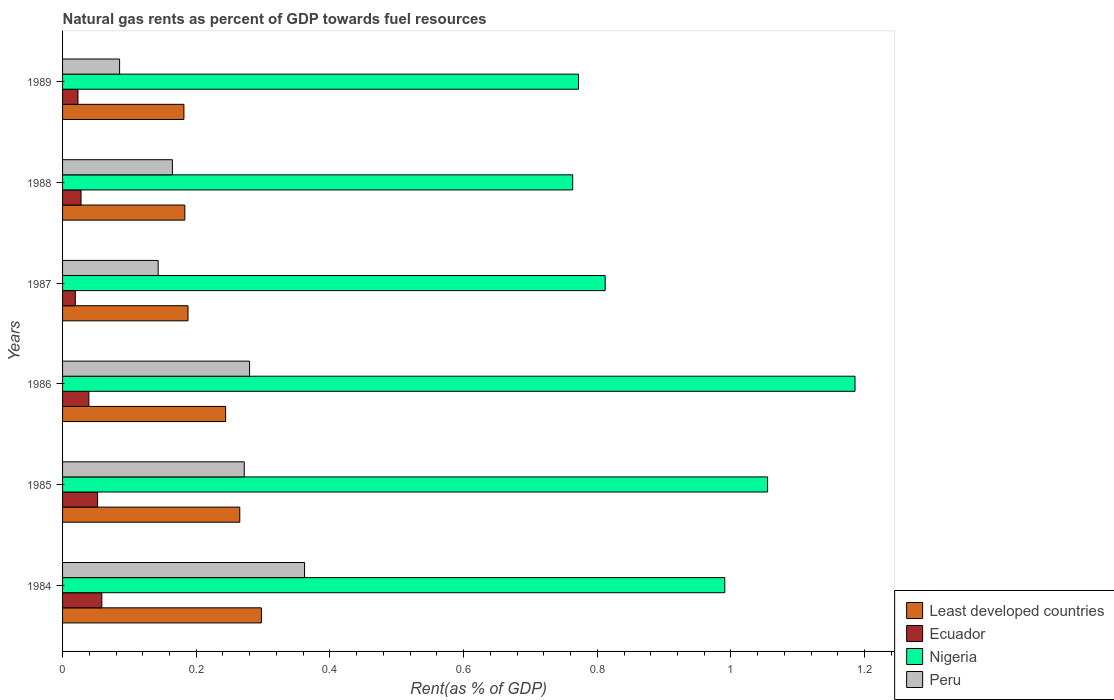How many different coloured bars are there?
Make the answer very short. 4. What is the matural gas rent in Nigeria in 1985?
Offer a terse response. 1.05. Across all years, what is the maximum matural gas rent in Ecuador?
Keep it short and to the point. 0.06. Across all years, what is the minimum matural gas rent in Ecuador?
Ensure brevity in your answer.  0.02. In which year was the matural gas rent in Ecuador maximum?
Ensure brevity in your answer.  1984. In which year was the matural gas rent in Nigeria minimum?
Your response must be concise. 1988. What is the total matural gas rent in Least developed countries in the graph?
Offer a very short reply. 1.36. What is the difference between the matural gas rent in Ecuador in 1984 and that in 1985?
Your response must be concise. 0.01. What is the difference between the matural gas rent in Ecuador in 1985 and the matural gas rent in Nigeria in 1986?
Ensure brevity in your answer.  -1.13. What is the average matural gas rent in Least developed countries per year?
Ensure brevity in your answer.  0.23. In the year 1987, what is the difference between the matural gas rent in Peru and matural gas rent in Nigeria?
Make the answer very short. -0.67. What is the ratio of the matural gas rent in Least developed countries in 1984 to that in 1988?
Give a very brief answer. 1.63. Is the matural gas rent in Nigeria in 1986 less than that in 1987?
Offer a very short reply. No. What is the difference between the highest and the second highest matural gas rent in Nigeria?
Offer a terse response. 0.13. What is the difference between the highest and the lowest matural gas rent in Least developed countries?
Make the answer very short. 0.12. Is the sum of the matural gas rent in Nigeria in 1986 and 1988 greater than the maximum matural gas rent in Least developed countries across all years?
Keep it short and to the point. Yes. What does the 1st bar from the top in 1987 represents?
Your answer should be very brief. Peru. What does the 2nd bar from the bottom in 1986 represents?
Provide a succinct answer. Ecuador. Are all the bars in the graph horizontal?
Give a very brief answer. Yes. How many years are there in the graph?
Your response must be concise. 6. Are the values on the major ticks of X-axis written in scientific E-notation?
Your answer should be compact. No. Does the graph contain any zero values?
Your answer should be compact. No. Does the graph contain grids?
Make the answer very short. No. Where does the legend appear in the graph?
Give a very brief answer. Bottom right. How many legend labels are there?
Your answer should be compact. 4. What is the title of the graph?
Provide a succinct answer. Natural gas rents as percent of GDP towards fuel resources. Does "Cayman Islands" appear as one of the legend labels in the graph?
Provide a short and direct response. No. What is the label or title of the X-axis?
Your response must be concise. Rent(as % of GDP). What is the label or title of the Y-axis?
Provide a short and direct response. Years. What is the Rent(as % of GDP) of Least developed countries in 1984?
Your answer should be very brief. 0.3. What is the Rent(as % of GDP) in Ecuador in 1984?
Offer a very short reply. 0.06. What is the Rent(as % of GDP) in Nigeria in 1984?
Ensure brevity in your answer.  0.99. What is the Rent(as % of GDP) in Peru in 1984?
Provide a succinct answer. 0.36. What is the Rent(as % of GDP) of Least developed countries in 1985?
Your answer should be compact. 0.27. What is the Rent(as % of GDP) in Ecuador in 1985?
Your answer should be compact. 0.05. What is the Rent(as % of GDP) in Nigeria in 1985?
Keep it short and to the point. 1.05. What is the Rent(as % of GDP) in Peru in 1985?
Your response must be concise. 0.27. What is the Rent(as % of GDP) in Least developed countries in 1986?
Offer a very short reply. 0.24. What is the Rent(as % of GDP) of Ecuador in 1986?
Give a very brief answer. 0.04. What is the Rent(as % of GDP) of Nigeria in 1986?
Your answer should be very brief. 1.19. What is the Rent(as % of GDP) of Peru in 1986?
Your answer should be very brief. 0.28. What is the Rent(as % of GDP) in Least developed countries in 1987?
Ensure brevity in your answer.  0.19. What is the Rent(as % of GDP) of Ecuador in 1987?
Give a very brief answer. 0.02. What is the Rent(as % of GDP) of Nigeria in 1987?
Offer a terse response. 0.81. What is the Rent(as % of GDP) of Peru in 1987?
Provide a succinct answer. 0.14. What is the Rent(as % of GDP) in Least developed countries in 1988?
Your answer should be compact. 0.18. What is the Rent(as % of GDP) of Ecuador in 1988?
Your answer should be compact. 0.03. What is the Rent(as % of GDP) of Nigeria in 1988?
Offer a very short reply. 0.76. What is the Rent(as % of GDP) in Peru in 1988?
Provide a succinct answer. 0.16. What is the Rent(as % of GDP) of Least developed countries in 1989?
Offer a very short reply. 0.18. What is the Rent(as % of GDP) in Ecuador in 1989?
Your answer should be very brief. 0.02. What is the Rent(as % of GDP) of Nigeria in 1989?
Make the answer very short. 0.77. What is the Rent(as % of GDP) of Peru in 1989?
Provide a short and direct response. 0.09. Across all years, what is the maximum Rent(as % of GDP) of Least developed countries?
Your answer should be compact. 0.3. Across all years, what is the maximum Rent(as % of GDP) of Ecuador?
Offer a very short reply. 0.06. Across all years, what is the maximum Rent(as % of GDP) of Nigeria?
Provide a short and direct response. 1.19. Across all years, what is the maximum Rent(as % of GDP) of Peru?
Ensure brevity in your answer.  0.36. Across all years, what is the minimum Rent(as % of GDP) in Least developed countries?
Provide a short and direct response. 0.18. Across all years, what is the minimum Rent(as % of GDP) in Ecuador?
Offer a very short reply. 0.02. Across all years, what is the minimum Rent(as % of GDP) of Nigeria?
Offer a very short reply. 0.76. Across all years, what is the minimum Rent(as % of GDP) of Peru?
Make the answer very short. 0.09. What is the total Rent(as % of GDP) of Least developed countries in the graph?
Your answer should be very brief. 1.36. What is the total Rent(as % of GDP) of Ecuador in the graph?
Give a very brief answer. 0.22. What is the total Rent(as % of GDP) of Nigeria in the graph?
Your response must be concise. 5.58. What is the total Rent(as % of GDP) of Peru in the graph?
Your answer should be compact. 1.31. What is the difference between the Rent(as % of GDP) in Least developed countries in 1984 and that in 1985?
Your answer should be compact. 0.03. What is the difference between the Rent(as % of GDP) of Ecuador in 1984 and that in 1985?
Provide a succinct answer. 0.01. What is the difference between the Rent(as % of GDP) of Nigeria in 1984 and that in 1985?
Your answer should be very brief. -0.06. What is the difference between the Rent(as % of GDP) of Peru in 1984 and that in 1985?
Offer a terse response. 0.09. What is the difference between the Rent(as % of GDP) in Least developed countries in 1984 and that in 1986?
Offer a very short reply. 0.05. What is the difference between the Rent(as % of GDP) of Ecuador in 1984 and that in 1986?
Ensure brevity in your answer.  0.02. What is the difference between the Rent(as % of GDP) of Nigeria in 1984 and that in 1986?
Offer a very short reply. -0.19. What is the difference between the Rent(as % of GDP) in Peru in 1984 and that in 1986?
Your answer should be compact. 0.08. What is the difference between the Rent(as % of GDP) of Least developed countries in 1984 and that in 1987?
Your answer should be compact. 0.11. What is the difference between the Rent(as % of GDP) in Ecuador in 1984 and that in 1987?
Your answer should be very brief. 0.04. What is the difference between the Rent(as % of GDP) of Nigeria in 1984 and that in 1987?
Offer a very short reply. 0.18. What is the difference between the Rent(as % of GDP) of Peru in 1984 and that in 1987?
Keep it short and to the point. 0.22. What is the difference between the Rent(as % of GDP) of Least developed countries in 1984 and that in 1988?
Provide a succinct answer. 0.11. What is the difference between the Rent(as % of GDP) of Ecuador in 1984 and that in 1988?
Give a very brief answer. 0.03. What is the difference between the Rent(as % of GDP) in Nigeria in 1984 and that in 1988?
Your answer should be compact. 0.23. What is the difference between the Rent(as % of GDP) of Peru in 1984 and that in 1988?
Provide a short and direct response. 0.2. What is the difference between the Rent(as % of GDP) of Least developed countries in 1984 and that in 1989?
Give a very brief answer. 0.12. What is the difference between the Rent(as % of GDP) in Ecuador in 1984 and that in 1989?
Your response must be concise. 0.04. What is the difference between the Rent(as % of GDP) of Nigeria in 1984 and that in 1989?
Offer a terse response. 0.22. What is the difference between the Rent(as % of GDP) of Peru in 1984 and that in 1989?
Make the answer very short. 0.28. What is the difference between the Rent(as % of GDP) of Least developed countries in 1985 and that in 1986?
Make the answer very short. 0.02. What is the difference between the Rent(as % of GDP) in Ecuador in 1985 and that in 1986?
Provide a succinct answer. 0.01. What is the difference between the Rent(as % of GDP) in Nigeria in 1985 and that in 1986?
Offer a terse response. -0.13. What is the difference between the Rent(as % of GDP) in Peru in 1985 and that in 1986?
Give a very brief answer. -0.01. What is the difference between the Rent(as % of GDP) of Least developed countries in 1985 and that in 1987?
Offer a terse response. 0.08. What is the difference between the Rent(as % of GDP) of Nigeria in 1985 and that in 1987?
Your answer should be very brief. 0.24. What is the difference between the Rent(as % of GDP) in Peru in 1985 and that in 1987?
Your answer should be very brief. 0.13. What is the difference between the Rent(as % of GDP) of Least developed countries in 1985 and that in 1988?
Offer a terse response. 0.08. What is the difference between the Rent(as % of GDP) of Ecuador in 1985 and that in 1988?
Give a very brief answer. 0.02. What is the difference between the Rent(as % of GDP) in Nigeria in 1985 and that in 1988?
Your answer should be compact. 0.29. What is the difference between the Rent(as % of GDP) of Peru in 1985 and that in 1988?
Your response must be concise. 0.11. What is the difference between the Rent(as % of GDP) in Least developed countries in 1985 and that in 1989?
Offer a terse response. 0.08. What is the difference between the Rent(as % of GDP) in Ecuador in 1985 and that in 1989?
Provide a short and direct response. 0.03. What is the difference between the Rent(as % of GDP) in Nigeria in 1985 and that in 1989?
Offer a very short reply. 0.28. What is the difference between the Rent(as % of GDP) of Peru in 1985 and that in 1989?
Your answer should be very brief. 0.19. What is the difference between the Rent(as % of GDP) of Least developed countries in 1986 and that in 1987?
Your response must be concise. 0.06. What is the difference between the Rent(as % of GDP) in Ecuador in 1986 and that in 1987?
Provide a succinct answer. 0.02. What is the difference between the Rent(as % of GDP) in Nigeria in 1986 and that in 1987?
Provide a short and direct response. 0.37. What is the difference between the Rent(as % of GDP) in Peru in 1986 and that in 1987?
Your answer should be very brief. 0.14. What is the difference between the Rent(as % of GDP) of Least developed countries in 1986 and that in 1988?
Your response must be concise. 0.06. What is the difference between the Rent(as % of GDP) in Ecuador in 1986 and that in 1988?
Offer a terse response. 0.01. What is the difference between the Rent(as % of GDP) in Nigeria in 1986 and that in 1988?
Give a very brief answer. 0.42. What is the difference between the Rent(as % of GDP) of Peru in 1986 and that in 1988?
Make the answer very short. 0.12. What is the difference between the Rent(as % of GDP) of Least developed countries in 1986 and that in 1989?
Provide a short and direct response. 0.06. What is the difference between the Rent(as % of GDP) in Ecuador in 1986 and that in 1989?
Your answer should be very brief. 0.02. What is the difference between the Rent(as % of GDP) of Nigeria in 1986 and that in 1989?
Give a very brief answer. 0.41. What is the difference between the Rent(as % of GDP) of Peru in 1986 and that in 1989?
Ensure brevity in your answer.  0.19. What is the difference between the Rent(as % of GDP) in Least developed countries in 1987 and that in 1988?
Give a very brief answer. 0. What is the difference between the Rent(as % of GDP) of Ecuador in 1987 and that in 1988?
Your response must be concise. -0.01. What is the difference between the Rent(as % of GDP) in Nigeria in 1987 and that in 1988?
Your response must be concise. 0.05. What is the difference between the Rent(as % of GDP) of Peru in 1987 and that in 1988?
Offer a very short reply. -0.02. What is the difference between the Rent(as % of GDP) of Least developed countries in 1987 and that in 1989?
Ensure brevity in your answer.  0.01. What is the difference between the Rent(as % of GDP) in Ecuador in 1987 and that in 1989?
Your response must be concise. -0. What is the difference between the Rent(as % of GDP) of Nigeria in 1987 and that in 1989?
Provide a short and direct response. 0.04. What is the difference between the Rent(as % of GDP) in Peru in 1987 and that in 1989?
Give a very brief answer. 0.06. What is the difference between the Rent(as % of GDP) of Least developed countries in 1988 and that in 1989?
Your answer should be compact. 0. What is the difference between the Rent(as % of GDP) of Ecuador in 1988 and that in 1989?
Offer a very short reply. 0. What is the difference between the Rent(as % of GDP) of Nigeria in 1988 and that in 1989?
Offer a very short reply. -0.01. What is the difference between the Rent(as % of GDP) in Peru in 1988 and that in 1989?
Offer a very short reply. 0.08. What is the difference between the Rent(as % of GDP) of Least developed countries in 1984 and the Rent(as % of GDP) of Ecuador in 1985?
Your answer should be very brief. 0.25. What is the difference between the Rent(as % of GDP) of Least developed countries in 1984 and the Rent(as % of GDP) of Nigeria in 1985?
Your answer should be compact. -0.76. What is the difference between the Rent(as % of GDP) in Least developed countries in 1984 and the Rent(as % of GDP) in Peru in 1985?
Provide a short and direct response. 0.03. What is the difference between the Rent(as % of GDP) of Ecuador in 1984 and the Rent(as % of GDP) of Nigeria in 1985?
Give a very brief answer. -1. What is the difference between the Rent(as % of GDP) in Ecuador in 1984 and the Rent(as % of GDP) in Peru in 1985?
Offer a terse response. -0.21. What is the difference between the Rent(as % of GDP) of Nigeria in 1984 and the Rent(as % of GDP) of Peru in 1985?
Your response must be concise. 0.72. What is the difference between the Rent(as % of GDP) of Least developed countries in 1984 and the Rent(as % of GDP) of Ecuador in 1986?
Offer a terse response. 0.26. What is the difference between the Rent(as % of GDP) in Least developed countries in 1984 and the Rent(as % of GDP) in Nigeria in 1986?
Give a very brief answer. -0.89. What is the difference between the Rent(as % of GDP) of Least developed countries in 1984 and the Rent(as % of GDP) of Peru in 1986?
Offer a terse response. 0.02. What is the difference between the Rent(as % of GDP) of Ecuador in 1984 and the Rent(as % of GDP) of Nigeria in 1986?
Ensure brevity in your answer.  -1.13. What is the difference between the Rent(as % of GDP) of Ecuador in 1984 and the Rent(as % of GDP) of Peru in 1986?
Keep it short and to the point. -0.22. What is the difference between the Rent(as % of GDP) in Nigeria in 1984 and the Rent(as % of GDP) in Peru in 1986?
Give a very brief answer. 0.71. What is the difference between the Rent(as % of GDP) in Least developed countries in 1984 and the Rent(as % of GDP) in Ecuador in 1987?
Provide a short and direct response. 0.28. What is the difference between the Rent(as % of GDP) in Least developed countries in 1984 and the Rent(as % of GDP) in Nigeria in 1987?
Keep it short and to the point. -0.51. What is the difference between the Rent(as % of GDP) of Least developed countries in 1984 and the Rent(as % of GDP) of Peru in 1987?
Ensure brevity in your answer.  0.15. What is the difference between the Rent(as % of GDP) of Ecuador in 1984 and the Rent(as % of GDP) of Nigeria in 1987?
Ensure brevity in your answer.  -0.75. What is the difference between the Rent(as % of GDP) in Ecuador in 1984 and the Rent(as % of GDP) in Peru in 1987?
Keep it short and to the point. -0.08. What is the difference between the Rent(as % of GDP) in Nigeria in 1984 and the Rent(as % of GDP) in Peru in 1987?
Your response must be concise. 0.85. What is the difference between the Rent(as % of GDP) in Least developed countries in 1984 and the Rent(as % of GDP) in Ecuador in 1988?
Give a very brief answer. 0.27. What is the difference between the Rent(as % of GDP) of Least developed countries in 1984 and the Rent(as % of GDP) of Nigeria in 1988?
Your answer should be very brief. -0.47. What is the difference between the Rent(as % of GDP) of Least developed countries in 1984 and the Rent(as % of GDP) of Peru in 1988?
Keep it short and to the point. 0.13. What is the difference between the Rent(as % of GDP) of Ecuador in 1984 and the Rent(as % of GDP) of Nigeria in 1988?
Your answer should be very brief. -0.7. What is the difference between the Rent(as % of GDP) in Ecuador in 1984 and the Rent(as % of GDP) in Peru in 1988?
Your answer should be compact. -0.11. What is the difference between the Rent(as % of GDP) in Nigeria in 1984 and the Rent(as % of GDP) in Peru in 1988?
Keep it short and to the point. 0.83. What is the difference between the Rent(as % of GDP) in Least developed countries in 1984 and the Rent(as % of GDP) in Ecuador in 1989?
Ensure brevity in your answer.  0.27. What is the difference between the Rent(as % of GDP) in Least developed countries in 1984 and the Rent(as % of GDP) in Nigeria in 1989?
Your answer should be compact. -0.47. What is the difference between the Rent(as % of GDP) in Least developed countries in 1984 and the Rent(as % of GDP) in Peru in 1989?
Give a very brief answer. 0.21. What is the difference between the Rent(as % of GDP) in Ecuador in 1984 and the Rent(as % of GDP) in Nigeria in 1989?
Offer a very short reply. -0.71. What is the difference between the Rent(as % of GDP) of Ecuador in 1984 and the Rent(as % of GDP) of Peru in 1989?
Offer a terse response. -0.03. What is the difference between the Rent(as % of GDP) of Nigeria in 1984 and the Rent(as % of GDP) of Peru in 1989?
Make the answer very short. 0.91. What is the difference between the Rent(as % of GDP) in Least developed countries in 1985 and the Rent(as % of GDP) in Ecuador in 1986?
Your answer should be very brief. 0.23. What is the difference between the Rent(as % of GDP) in Least developed countries in 1985 and the Rent(as % of GDP) in Nigeria in 1986?
Provide a succinct answer. -0.92. What is the difference between the Rent(as % of GDP) of Least developed countries in 1985 and the Rent(as % of GDP) of Peru in 1986?
Provide a short and direct response. -0.01. What is the difference between the Rent(as % of GDP) of Ecuador in 1985 and the Rent(as % of GDP) of Nigeria in 1986?
Provide a succinct answer. -1.13. What is the difference between the Rent(as % of GDP) of Ecuador in 1985 and the Rent(as % of GDP) of Peru in 1986?
Your response must be concise. -0.23. What is the difference between the Rent(as % of GDP) of Nigeria in 1985 and the Rent(as % of GDP) of Peru in 1986?
Offer a terse response. 0.78. What is the difference between the Rent(as % of GDP) of Least developed countries in 1985 and the Rent(as % of GDP) of Ecuador in 1987?
Keep it short and to the point. 0.25. What is the difference between the Rent(as % of GDP) in Least developed countries in 1985 and the Rent(as % of GDP) in Nigeria in 1987?
Your answer should be very brief. -0.55. What is the difference between the Rent(as % of GDP) of Least developed countries in 1985 and the Rent(as % of GDP) of Peru in 1987?
Provide a succinct answer. 0.12. What is the difference between the Rent(as % of GDP) in Ecuador in 1985 and the Rent(as % of GDP) in Nigeria in 1987?
Your answer should be compact. -0.76. What is the difference between the Rent(as % of GDP) of Ecuador in 1985 and the Rent(as % of GDP) of Peru in 1987?
Make the answer very short. -0.09. What is the difference between the Rent(as % of GDP) of Nigeria in 1985 and the Rent(as % of GDP) of Peru in 1987?
Your answer should be compact. 0.91. What is the difference between the Rent(as % of GDP) of Least developed countries in 1985 and the Rent(as % of GDP) of Ecuador in 1988?
Your answer should be compact. 0.24. What is the difference between the Rent(as % of GDP) in Least developed countries in 1985 and the Rent(as % of GDP) in Nigeria in 1988?
Your answer should be compact. -0.5. What is the difference between the Rent(as % of GDP) of Least developed countries in 1985 and the Rent(as % of GDP) of Peru in 1988?
Your answer should be very brief. 0.1. What is the difference between the Rent(as % of GDP) in Ecuador in 1985 and the Rent(as % of GDP) in Nigeria in 1988?
Make the answer very short. -0.71. What is the difference between the Rent(as % of GDP) of Ecuador in 1985 and the Rent(as % of GDP) of Peru in 1988?
Keep it short and to the point. -0.11. What is the difference between the Rent(as % of GDP) in Nigeria in 1985 and the Rent(as % of GDP) in Peru in 1988?
Keep it short and to the point. 0.89. What is the difference between the Rent(as % of GDP) in Least developed countries in 1985 and the Rent(as % of GDP) in Ecuador in 1989?
Offer a very short reply. 0.24. What is the difference between the Rent(as % of GDP) in Least developed countries in 1985 and the Rent(as % of GDP) in Nigeria in 1989?
Your response must be concise. -0.51. What is the difference between the Rent(as % of GDP) in Least developed countries in 1985 and the Rent(as % of GDP) in Peru in 1989?
Provide a succinct answer. 0.18. What is the difference between the Rent(as % of GDP) of Ecuador in 1985 and the Rent(as % of GDP) of Nigeria in 1989?
Ensure brevity in your answer.  -0.72. What is the difference between the Rent(as % of GDP) in Ecuador in 1985 and the Rent(as % of GDP) in Peru in 1989?
Provide a short and direct response. -0.03. What is the difference between the Rent(as % of GDP) of Nigeria in 1985 and the Rent(as % of GDP) of Peru in 1989?
Ensure brevity in your answer.  0.97. What is the difference between the Rent(as % of GDP) in Least developed countries in 1986 and the Rent(as % of GDP) in Ecuador in 1987?
Provide a succinct answer. 0.22. What is the difference between the Rent(as % of GDP) of Least developed countries in 1986 and the Rent(as % of GDP) of Nigeria in 1987?
Keep it short and to the point. -0.57. What is the difference between the Rent(as % of GDP) of Least developed countries in 1986 and the Rent(as % of GDP) of Peru in 1987?
Provide a succinct answer. 0.1. What is the difference between the Rent(as % of GDP) of Ecuador in 1986 and the Rent(as % of GDP) of Nigeria in 1987?
Ensure brevity in your answer.  -0.77. What is the difference between the Rent(as % of GDP) of Ecuador in 1986 and the Rent(as % of GDP) of Peru in 1987?
Offer a very short reply. -0.1. What is the difference between the Rent(as % of GDP) of Nigeria in 1986 and the Rent(as % of GDP) of Peru in 1987?
Provide a succinct answer. 1.04. What is the difference between the Rent(as % of GDP) of Least developed countries in 1986 and the Rent(as % of GDP) of Ecuador in 1988?
Keep it short and to the point. 0.22. What is the difference between the Rent(as % of GDP) of Least developed countries in 1986 and the Rent(as % of GDP) of Nigeria in 1988?
Keep it short and to the point. -0.52. What is the difference between the Rent(as % of GDP) of Least developed countries in 1986 and the Rent(as % of GDP) of Peru in 1988?
Your answer should be compact. 0.08. What is the difference between the Rent(as % of GDP) of Ecuador in 1986 and the Rent(as % of GDP) of Nigeria in 1988?
Keep it short and to the point. -0.72. What is the difference between the Rent(as % of GDP) in Ecuador in 1986 and the Rent(as % of GDP) in Peru in 1988?
Make the answer very short. -0.12. What is the difference between the Rent(as % of GDP) of Nigeria in 1986 and the Rent(as % of GDP) of Peru in 1988?
Provide a succinct answer. 1.02. What is the difference between the Rent(as % of GDP) in Least developed countries in 1986 and the Rent(as % of GDP) in Ecuador in 1989?
Your answer should be compact. 0.22. What is the difference between the Rent(as % of GDP) in Least developed countries in 1986 and the Rent(as % of GDP) in Nigeria in 1989?
Offer a very short reply. -0.53. What is the difference between the Rent(as % of GDP) in Least developed countries in 1986 and the Rent(as % of GDP) in Peru in 1989?
Keep it short and to the point. 0.16. What is the difference between the Rent(as % of GDP) of Ecuador in 1986 and the Rent(as % of GDP) of Nigeria in 1989?
Provide a succinct answer. -0.73. What is the difference between the Rent(as % of GDP) of Ecuador in 1986 and the Rent(as % of GDP) of Peru in 1989?
Keep it short and to the point. -0.05. What is the difference between the Rent(as % of GDP) of Nigeria in 1986 and the Rent(as % of GDP) of Peru in 1989?
Keep it short and to the point. 1.1. What is the difference between the Rent(as % of GDP) in Least developed countries in 1987 and the Rent(as % of GDP) in Ecuador in 1988?
Provide a short and direct response. 0.16. What is the difference between the Rent(as % of GDP) of Least developed countries in 1987 and the Rent(as % of GDP) of Nigeria in 1988?
Give a very brief answer. -0.58. What is the difference between the Rent(as % of GDP) of Least developed countries in 1987 and the Rent(as % of GDP) of Peru in 1988?
Keep it short and to the point. 0.02. What is the difference between the Rent(as % of GDP) in Ecuador in 1987 and the Rent(as % of GDP) in Nigeria in 1988?
Provide a succinct answer. -0.74. What is the difference between the Rent(as % of GDP) of Ecuador in 1987 and the Rent(as % of GDP) of Peru in 1988?
Give a very brief answer. -0.15. What is the difference between the Rent(as % of GDP) of Nigeria in 1987 and the Rent(as % of GDP) of Peru in 1988?
Give a very brief answer. 0.65. What is the difference between the Rent(as % of GDP) of Least developed countries in 1987 and the Rent(as % of GDP) of Ecuador in 1989?
Offer a very short reply. 0.16. What is the difference between the Rent(as % of GDP) of Least developed countries in 1987 and the Rent(as % of GDP) of Nigeria in 1989?
Provide a short and direct response. -0.58. What is the difference between the Rent(as % of GDP) in Least developed countries in 1987 and the Rent(as % of GDP) in Peru in 1989?
Ensure brevity in your answer.  0.1. What is the difference between the Rent(as % of GDP) in Ecuador in 1987 and the Rent(as % of GDP) in Nigeria in 1989?
Your answer should be very brief. -0.75. What is the difference between the Rent(as % of GDP) of Ecuador in 1987 and the Rent(as % of GDP) of Peru in 1989?
Offer a very short reply. -0.07. What is the difference between the Rent(as % of GDP) in Nigeria in 1987 and the Rent(as % of GDP) in Peru in 1989?
Provide a succinct answer. 0.73. What is the difference between the Rent(as % of GDP) of Least developed countries in 1988 and the Rent(as % of GDP) of Ecuador in 1989?
Offer a very short reply. 0.16. What is the difference between the Rent(as % of GDP) in Least developed countries in 1988 and the Rent(as % of GDP) in Nigeria in 1989?
Provide a short and direct response. -0.59. What is the difference between the Rent(as % of GDP) of Least developed countries in 1988 and the Rent(as % of GDP) of Peru in 1989?
Keep it short and to the point. 0.1. What is the difference between the Rent(as % of GDP) of Ecuador in 1988 and the Rent(as % of GDP) of Nigeria in 1989?
Make the answer very short. -0.74. What is the difference between the Rent(as % of GDP) of Ecuador in 1988 and the Rent(as % of GDP) of Peru in 1989?
Your response must be concise. -0.06. What is the difference between the Rent(as % of GDP) of Nigeria in 1988 and the Rent(as % of GDP) of Peru in 1989?
Offer a terse response. 0.68. What is the average Rent(as % of GDP) in Least developed countries per year?
Your answer should be compact. 0.23. What is the average Rent(as % of GDP) in Ecuador per year?
Provide a succinct answer. 0.04. What is the average Rent(as % of GDP) of Nigeria per year?
Provide a short and direct response. 0.93. What is the average Rent(as % of GDP) of Peru per year?
Make the answer very short. 0.22. In the year 1984, what is the difference between the Rent(as % of GDP) in Least developed countries and Rent(as % of GDP) in Ecuador?
Offer a terse response. 0.24. In the year 1984, what is the difference between the Rent(as % of GDP) of Least developed countries and Rent(as % of GDP) of Nigeria?
Your response must be concise. -0.69. In the year 1984, what is the difference between the Rent(as % of GDP) in Least developed countries and Rent(as % of GDP) in Peru?
Ensure brevity in your answer.  -0.06. In the year 1984, what is the difference between the Rent(as % of GDP) in Ecuador and Rent(as % of GDP) in Nigeria?
Give a very brief answer. -0.93. In the year 1984, what is the difference between the Rent(as % of GDP) in Ecuador and Rent(as % of GDP) in Peru?
Provide a succinct answer. -0.3. In the year 1984, what is the difference between the Rent(as % of GDP) of Nigeria and Rent(as % of GDP) of Peru?
Keep it short and to the point. 0.63. In the year 1985, what is the difference between the Rent(as % of GDP) in Least developed countries and Rent(as % of GDP) in Ecuador?
Make the answer very short. 0.21. In the year 1985, what is the difference between the Rent(as % of GDP) in Least developed countries and Rent(as % of GDP) in Nigeria?
Your answer should be very brief. -0.79. In the year 1985, what is the difference between the Rent(as % of GDP) in Least developed countries and Rent(as % of GDP) in Peru?
Give a very brief answer. -0.01. In the year 1985, what is the difference between the Rent(as % of GDP) of Ecuador and Rent(as % of GDP) of Nigeria?
Your answer should be compact. -1. In the year 1985, what is the difference between the Rent(as % of GDP) in Ecuador and Rent(as % of GDP) in Peru?
Your answer should be compact. -0.22. In the year 1985, what is the difference between the Rent(as % of GDP) of Nigeria and Rent(as % of GDP) of Peru?
Your answer should be compact. 0.78. In the year 1986, what is the difference between the Rent(as % of GDP) in Least developed countries and Rent(as % of GDP) in Ecuador?
Give a very brief answer. 0.2. In the year 1986, what is the difference between the Rent(as % of GDP) in Least developed countries and Rent(as % of GDP) in Nigeria?
Your response must be concise. -0.94. In the year 1986, what is the difference between the Rent(as % of GDP) of Least developed countries and Rent(as % of GDP) of Peru?
Offer a terse response. -0.04. In the year 1986, what is the difference between the Rent(as % of GDP) in Ecuador and Rent(as % of GDP) in Nigeria?
Your response must be concise. -1.15. In the year 1986, what is the difference between the Rent(as % of GDP) of Ecuador and Rent(as % of GDP) of Peru?
Your answer should be very brief. -0.24. In the year 1986, what is the difference between the Rent(as % of GDP) in Nigeria and Rent(as % of GDP) in Peru?
Offer a very short reply. 0.91. In the year 1987, what is the difference between the Rent(as % of GDP) of Least developed countries and Rent(as % of GDP) of Ecuador?
Your answer should be compact. 0.17. In the year 1987, what is the difference between the Rent(as % of GDP) in Least developed countries and Rent(as % of GDP) in Nigeria?
Make the answer very short. -0.62. In the year 1987, what is the difference between the Rent(as % of GDP) of Least developed countries and Rent(as % of GDP) of Peru?
Keep it short and to the point. 0.04. In the year 1987, what is the difference between the Rent(as % of GDP) in Ecuador and Rent(as % of GDP) in Nigeria?
Provide a short and direct response. -0.79. In the year 1987, what is the difference between the Rent(as % of GDP) in Ecuador and Rent(as % of GDP) in Peru?
Ensure brevity in your answer.  -0.12. In the year 1987, what is the difference between the Rent(as % of GDP) of Nigeria and Rent(as % of GDP) of Peru?
Offer a terse response. 0.67. In the year 1988, what is the difference between the Rent(as % of GDP) in Least developed countries and Rent(as % of GDP) in Ecuador?
Provide a succinct answer. 0.16. In the year 1988, what is the difference between the Rent(as % of GDP) in Least developed countries and Rent(as % of GDP) in Nigeria?
Your response must be concise. -0.58. In the year 1988, what is the difference between the Rent(as % of GDP) in Least developed countries and Rent(as % of GDP) in Peru?
Keep it short and to the point. 0.02. In the year 1988, what is the difference between the Rent(as % of GDP) in Ecuador and Rent(as % of GDP) in Nigeria?
Provide a succinct answer. -0.74. In the year 1988, what is the difference between the Rent(as % of GDP) of Ecuador and Rent(as % of GDP) of Peru?
Provide a succinct answer. -0.14. In the year 1988, what is the difference between the Rent(as % of GDP) of Nigeria and Rent(as % of GDP) of Peru?
Give a very brief answer. 0.6. In the year 1989, what is the difference between the Rent(as % of GDP) of Least developed countries and Rent(as % of GDP) of Ecuador?
Your answer should be compact. 0.16. In the year 1989, what is the difference between the Rent(as % of GDP) of Least developed countries and Rent(as % of GDP) of Nigeria?
Provide a short and direct response. -0.59. In the year 1989, what is the difference between the Rent(as % of GDP) in Least developed countries and Rent(as % of GDP) in Peru?
Offer a very short reply. 0.1. In the year 1989, what is the difference between the Rent(as % of GDP) in Ecuador and Rent(as % of GDP) in Nigeria?
Offer a terse response. -0.75. In the year 1989, what is the difference between the Rent(as % of GDP) of Ecuador and Rent(as % of GDP) of Peru?
Offer a very short reply. -0.06. In the year 1989, what is the difference between the Rent(as % of GDP) of Nigeria and Rent(as % of GDP) of Peru?
Provide a succinct answer. 0.69. What is the ratio of the Rent(as % of GDP) in Least developed countries in 1984 to that in 1985?
Offer a terse response. 1.12. What is the ratio of the Rent(as % of GDP) in Ecuador in 1984 to that in 1985?
Ensure brevity in your answer.  1.12. What is the ratio of the Rent(as % of GDP) in Nigeria in 1984 to that in 1985?
Keep it short and to the point. 0.94. What is the ratio of the Rent(as % of GDP) in Peru in 1984 to that in 1985?
Keep it short and to the point. 1.33. What is the ratio of the Rent(as % of GDP) in Least developed countries in 1984 to that in 1986?
Your response must be concise. 1.22. What is the ratio of the Rent(as % of GDP) in Ecuador in 1984 to that in 1986?
Ensure brevity in your answer.  1.49. What is the ratio of the Rent(as % of GDP) in Nigeria in 1984 to that in 1986?
Make the answer very short. 0.84. What is the ratio of the Rent(as % of GDP) in Peru in 1984 to that in 1986?
Make the answer very short. 1.29. What is the ratio of the Rent(as % of GDP) in Least developed countries in 1984 to that in 1987?
Offer a very short reply. 1.58. What is the ratio of the Rent(as % of GDP) in Ecuador in 1984 to that in 1987?
Offer a very short reply. 3.07. What is the ratio of the Rent(as % of GDP) of Nigeria in 1984 to that in 1987?
Offer a terse response. 1.22. What is the ratio of the Rent(as % of GDP) of Peru in 1984 to that in 1987?
Give a very brief answer. 2.53. What is the ratio of the Rent(as % of GDP) in Least developed countries in 1984 to that in 1988?
Offer a terse response. 1.63. What is the ratio of the Rent(as % of GDP) of Ecuador in 1984 to that in 1988?
Your response must be concise. 2.12. What is the ratio of the Rent(as % of GDP) in Nigeria in 1984 to that in 1988?
Offer a very short reply. 1.3. What is the ratio of the Rent(as % of GDP) of Peru in 1984 to that in 1988?
Offer a very short reply. 2.2. What is the ratio of the Rent(as % of GDP) of Least developed countries in 1984 to that in 1989?
Offer a terse response. 1.64. What is the ratio of the Rent(as % of GDP) in Ecuador in 1984 to that in 1989?
Offer a very short reply. 2.54. What is the ratio of the Rent(as % of GDP) of Nigeria in 1984 to that in 1989?
Offer a terse response. 1.28. What is the ratio of the Rent(as % of GDP) in Peru in 1984 to that in 1989?
Your answer should be compact. 4.24. What is the ratio of the Rent(as % of GDP) in Least developed countries in 1985 to that in 1986?
Your response must be concise. 1.09. What is the ratio of the Rent(as % of GDP) in Ecuador in 1985 to that in 1986?
Ensure brevity in your answer.  1.33. What is the ratio of the Rent(as % of GDP) in Nigeria in 1985 to that in 1986?
Provide a succinct answer. 0.89. What is the ratio of the Rent(as % of GDP) of Peru in 1985 to that in 1986?
Your answer should be compact. 0.97. What is the ratio of the Rent(as % of GDP) in Least developed countries in 1985 to that in 1987?
Ensure brevity in your answer.  1.41. What is the ratio of the Rent(as % of GDP) in Ecuador in 1985 to that in 1987?
Make the answer very short. 2.74. What is the ratio of the Rent(as % of GDP) in Nigeria in 1985 to that in 1987?
Keep it short and to the point. 1.3. What is the ratio of the Rent(as % of GDP) of Peru in 1985 to that in 1987?
Offer a very short reply. 1.9. What is the ratio of the Rent(as % of GDP) in Least developed countries in 1985 to that in 1988?
Give a very brief answer. 1.45. What is the ratio of the Rent(as % of GDP) in Ecuador in 1985 to that in 1988?
Your answer should be compact. 1.9. What is the ratio of the Rent(as % of GDP) of Nigeria in 1985 to that in 1988?
Provide a short and direct response. 1.38. What is the ratio of the Rent(as % of GDP) in Peru in 1985 to that in 1988?
Your answer should be very brief. 1.65. What is the ratio of the Rent(as % of GDP) in Least developed countries in 1985 to that in 1989?
Provide a short and direct response. 1.46. What is the ratio of the Rent(as % of GDP) in Ecuador in 1985 to that in 1989?
Provide a succinct answer. 2.27. What is the ratio of the Rent(as % of GDP) in Nigeria in 1985 to that in 1989?
Offer a very short reply. 1.37. What is the ratio of the Rent(as % of GDP) of Peru in 1985 to that in 1989?
Make the answer very short. 3.19. What is the ratio of the Rent(as % of GDP) of Least developed countries in 1986 to that in 1987?
Your answer should be very brief. 1.3. What is the ratio of the Rent(as % of GDP) in Ecuador in 1986 to that in 1987?
Provide a short and direct response. 2.06. What is the ratio of the Rent(as % of GDP) in Nigeria in 1986 to that in 1987?
Make the answer very short. 1.46. What is the ratio of the Rent(as % of GDP) in Peru in 1986 to that in 1987?
Make the answer very short. 1.96. What is the ratio of the Rent(as % of GDP) of Least developed countries in 1986 to that in 1988?
Ensure brevity in your answer.  1.33. What is the ratio of the Rent(as % of GDP) in Ecuador in 1986 to that in 1988?
Keep it short and to the point. 1.42. What is the ratio of the Rent(as % of GDP) of Nigeria in 1986 to that in 1988?
Provide a short and direct response. 1.55. What is the ratio of the Rent(as % of GDP) in Peru in 1986 to that in 1988?
Offer a very short reply. 1.7. What is the ratio of the Rent(as % of GDP) in Least developed countries in 1986 to that in 1989?
Your response must be concise. 1.34. What is the ratio of the Rent(as % of GDP) in Ecuador in 1986 to that in 1989?
Give a very brief answer. 1.7. What is the ratio of the Rent(as % of GDP) in Nigeria in 1986 to that in 1989?
Provide a short and direct response. 1.54. What is the ratio of the Rent(as % of GDP) of Peru in 1986 to that in 1989?
Provide a short and direct response. 3.28. What is the ratio of the Rent(as % of GDP) of Least developed countries in 1987 to that in 1988?
Keep it short and to the point. 1.03. What is the ratio of the Rent(as % of GDP) of Ecuador in 1987 to that in 1988?
Offer a very short reply. 0.69. What is the ratio of the Rent(as % of GDP) in Nigeria in 1987 to that in 1988?
Ensure brevity in your answer.  1.06. What is the ratio of the Rent(as % of GDP) in Peru in 1987 to that in 1988?
Ensure brevity in your answer.  0.87. What is the ratio of the Rent(as % of GDP) in Least developed countries in 1987 to that in 1989?
Give a very brief answer. 1.03. What is the ratio of the Rent(as % of GDP) in Ecuador in 1987 to that in 1989?
Your answer should be very brief. 0.83. What is the ratio of the Rent(as % of GDP) in Nigeria in 1987 to that in 1989?
Your answer should be very brief. 1.05. What is the ratio of the Rent(as % of GDP) of Peru in 1987 to that in 1989?
Offer a terse response. 1.68. What is the ratio of the Rent(as % of GDP) of Least developed countries in 1988 to that in 1989?
Your answer should be compact. 1.01. What is the ratio of the Rent(as % of GDP) of Ecuador in 1988 to that in 1989?
Offer a very short reply. 1.2. What is the ratio of the Rent(as % of GDP) in Nigeria in 1988 to that in 1989?
Provide a short and direct response. 0.99. What is the ratio of the Rent(as % of GDP) in Peru in 1988 to that in 1989?
Your answer should be compact. 1.93. What is the difference between the highest and the second highest Rent(as % of GDP) in Least developed countries?
Ensure brevity in your answer.  0.03. What is the difference between the highest and the second highest Rent(as % of GDP) of Ecuador?
Your answer should be very brief. 0.01. What is the difference between the highest and the second highest Rent(as % of GDP) in Nigeria?
Offer a terse response. 0.13. What is the difference between the highest and the second highest Rent(as % of GDP) of Peru?
Your answer should be very brief. 0.08. What is the difference between the highest and the lowest Rent(as % of GDP) of Least developed countries?
Give a very brief answer. 0.12. What is the difference between the highest and the lowest Rent(as % of GDP) in Ecuador?
Your answer should be compact. 0.04. What is the difference between the highest and the lowest Rent(as % of GDP) in Nigeria?
Your answer should be very brief. 0.42. What is the difference between the highest and the lowest Rent(as % of GDP) of Peru?
Your answer should be compact. 0.28. 